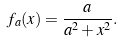<formula> <loc_0><loc_0><loc_500><loc_500>f _ { a } ( x ) = \frac { a } { a ^ { 2 } + x ^ { 2 } } .</formula> 